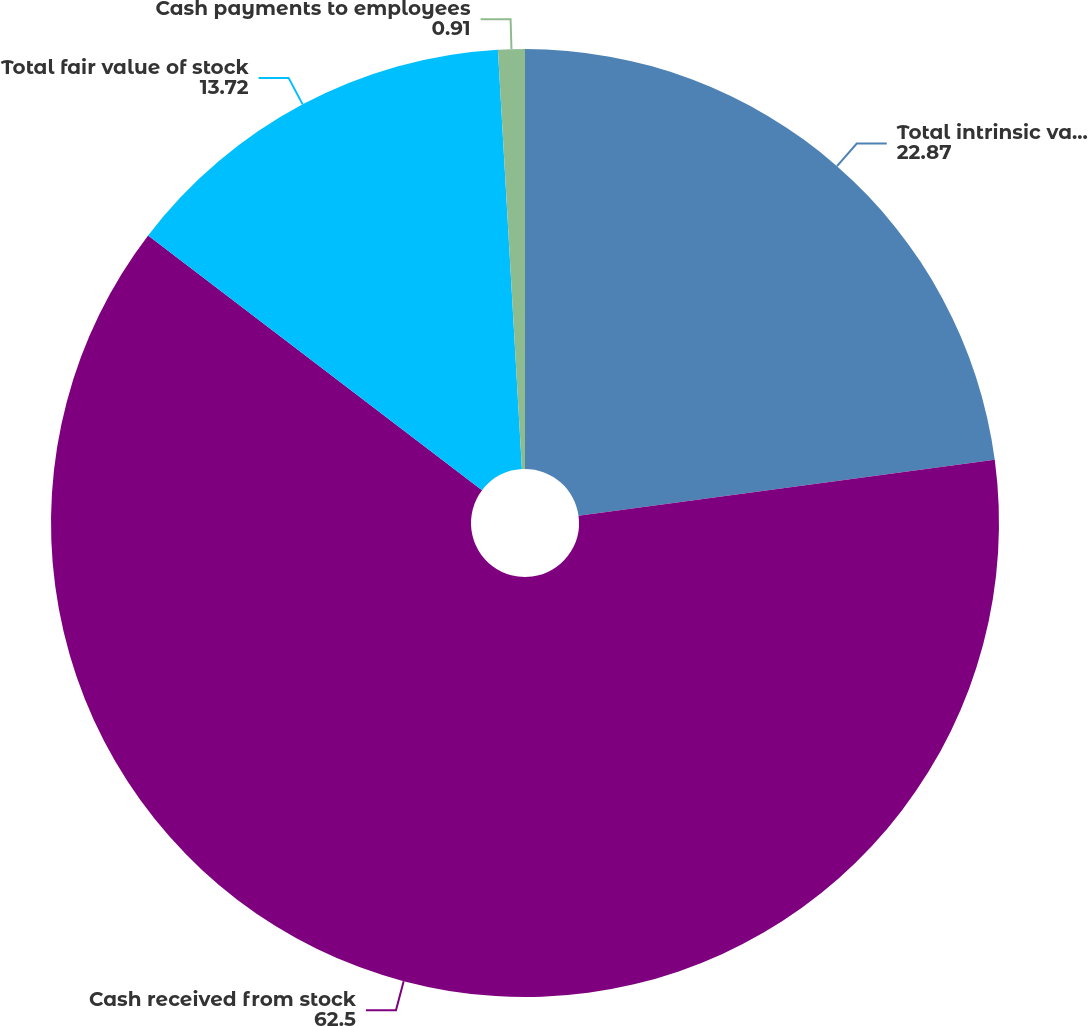<chart> <loc_0><loc_0><loc_500><loc_500><pie_chart><fcel>Total intrinsic value of stock<fcel>Cash received from stock<fcel>Total fair value of stock<fcel>Cash payments to employees<nl><fcel>22.87%<fcel>62.5%<fcel>13.72%<fcel>0.91%<nl></chart> 